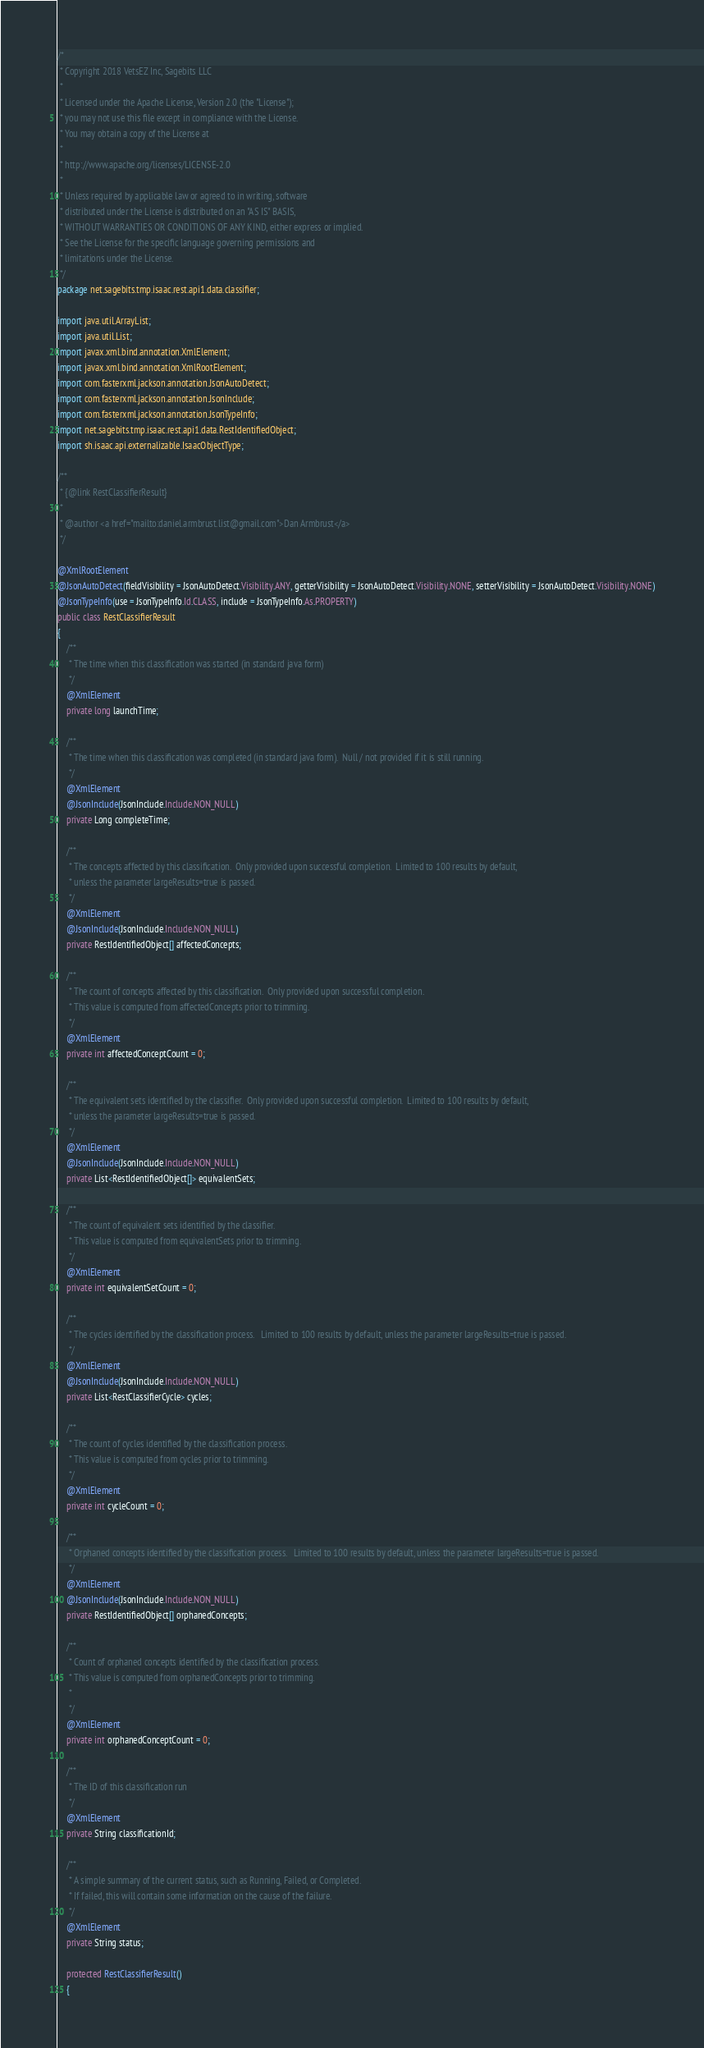Convert code to text. <code><loc_0><loc_0><loc_500><loc_500><_Java_>/*
 * Copyright 2018 VetsEZ Inc, Sagebits LLC
 *
 * Licensed under the Apache License, Version 2.0 (the "License");
 * you may not use this file except in compliance with the License.
 * You may obtain a copy of the License at
 *
 * http://www.apache.org/licenses/LICENSE-2.0
 *
 * Unless required by applicable law or agreed to in writing, software
 * distributed under the License is distributed on an "AS IS" BASIS,
 * WITHOUT WARRANTIES OR CONDITIONS OF ANY KIND, either express or implied.
 * See the License for the specific language governing permissions and
 * limitations under the License.
 */
package net.sagebits.tmp.isaac.rest.api1.data.classifier;

import java.util.ArrayList;
import java.util.List;
import javax.xml.bind.annotation.XmlElement;
import javax.xml.bind.annotation.XmlRootElement;
import com.fasterxml.jackson.annotation.JsonAutoDetect;
import com.fasterxml.jackson.annotation.JsonInclude;
import com.fasterxml.jackson.annotation.JsonTypeInfo;
import net.sagebits.tmp.isaac.rest.api1.data.RestIdentifiedObject;
import sh.isaac.api.externalizable.IsaacObjectType;

/**
 * {@link RestClassifierResult}
 *
 * @author <a href="mailto:daniel.armbrust.list@gmail.com">Dan Armbrust</a> 
 */

@XmlRootElement
@JsonAutoDetect(fieldVisibility = JsonAutoDetect.Visibility.ANY, getterVisibility = JsonAutoDetect.Visibility.NONE, setterVisibility = JsonAutoDetect.Visibility.NONE)
@JsonTypeInfo(use = JsonTypeInfo.Id.CLASS, include = JsonTypeInfo.As.PROPERTY)
public class RestClassifierResult
{
	/**
	 * The time when this classification was started (in standard java form)
	 */
	@XmlElement
	private long launchTime;
	
	/**
	 * The time when this classification was completed (in standard java form).  Null / not provided if it is still running.
	 */	
	@XmlElement
	@JsonInclude(JsonInclude.Include.NON_NULL)
	private Long completeTime;
	
	/**
	 * The concepts affected by this classification.  Only provided upon successful completion.  Limited to 100 results by default, 
	 * unless the parameter largeResults=true is passed.  
	 */
	@XmlElement
	@JsonInclude(JsonInclude.Include.NON_NULL)
	private RestIdentifiedObject[] affectedConcepts;
	
	/**
	 * The count of concepts affected by this classification.  Only provided upon successful completion.
	 * This value is computed from affectedConcepts prior to trimming.
	 */
	@XmlElement
	private int affectedConceptCount = 0;
	
	/**
	 * The equivalent sets identified by the classifier.  Only provided upon successful completion.  Limited to 100 results by default, 
	 * unless the parameter largeResults=true is passed.  
	 */
	@XmlElement
	@JsonInclude(JsonInclude.Include.NON_NULL)
	private List<RestIdentifiedObject[]> equivalentSets;
	
	/**
	 * The count of equivalent sets identified by the classifier.
	 * This value is computed from equivalentSets prior to trimming.  
	 */
	@XmlElement
	private int equivalentSetCount = 0;
	
	/**
	 * The cycles identified by the classification process.   Limited to 100 results by default, unless the parameter largeResults=true is passed.
	 */
	@XmlElement
	@JsonInclude(JsonInclude.Include.NON_NULL)
	private List<RestClassifierCycle> cycles;
	
	/**
	 * The count of cycles identified by the classification process.
	 * This value is computed from cycles prior to trimming.  
	 */
	@XmlElement
	private int cycleCount = 0;
	
	/**
	 * Orphaned concepts identified by the classification process.   Limited to 100 results by default, unless the parameter largeResults=true is passed.
	 */
	@XmlElement
	@JsonInclude(JsonInclude.Include.NON_NULL)
	private RestIdentifiedObject[] orphanedConcepts;
	
	/**
	 * Count of orphaned concepts identified by the classification process. 
	 * This value is computed from orphanedConcepts prior to trimming.  
	 * 
	 */
	@XmlElement
	private int orphanedConceptCount = 0;
	
	/**
	 * The ID of this classification run
	 */
	@XmlElement
	private String classificationId;
	
	/**
	 * A simple summary of the current status, such as Running, Failed, or Completed.
	 * If failed, this will contain some information on the cause of the failure.
	 */
	@XmlElement
	private String status;
	
	protected RestClassifierResult()
	{</code> 